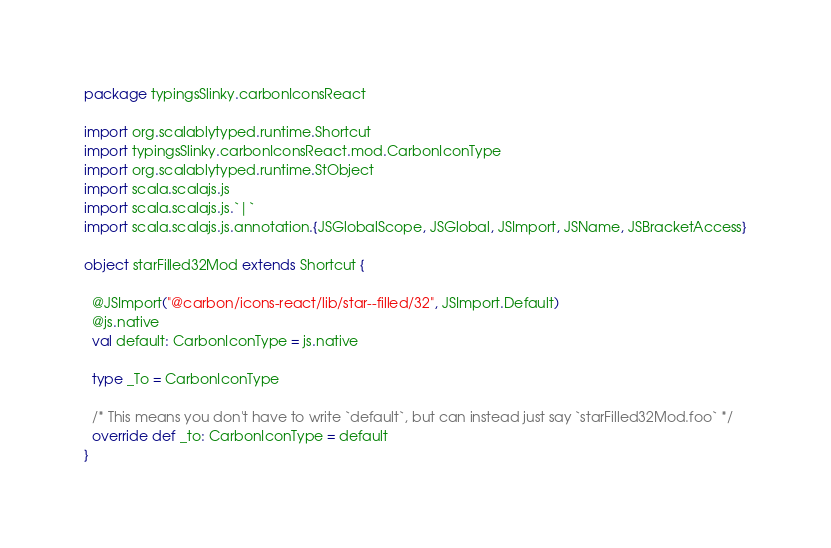<code> <loc_0><loc_0><loc_500><loc_500><_Scala_>package typingsSlinky.carbonIconsReact

import org.scalablytyped.runtime.Shortcut
import typingsSlinky.carbonIconsReact.mod.CarbonIconType
import org.scalablytyped.runtime.StObject
import scala.scalajs.js
import scala.scalajs.js.`|`
import scala.scalajs.js.annotation.{JSGlobalScope, JSGlobal, JSImport, JSName, JSBracketAccess}

object starFilled32Mod extends Shortcut {
  
  @JSImport("@carbon/icons-react/lib/star--filled/32", JSImport.Default)
  @js.native
  val default: CarbonIconType = js.native
  
  type _To = CarbonIconType
  
  /* This means you don't have to write `default`, but can instead just say `starFilled32Mod.foo` */
  override def _to: CarbonIconType = default
}
</code> 